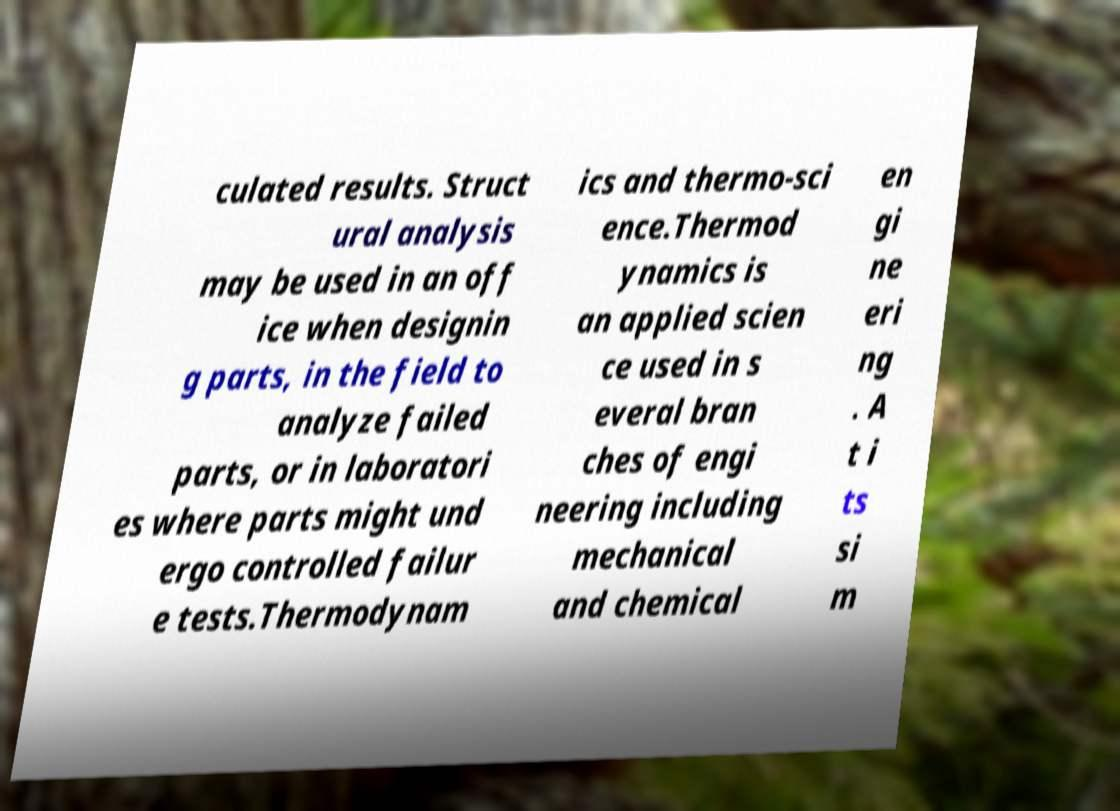For documentation purposes, I need the text within this image transcribed. Could you provide that? culated results. Struct ural analysis may be used in an off ice when designin g parts, in the field to analyze failed parts, or in laboratori es where parts might und ergo controlled failur e tests.Thermodynam ics and thermo-sci ence.Thermod ynamics is an applied scien ce used in s everal bran ches of engi neering including mechanical and chemical en gi ne eri ng . A t i ts si m 